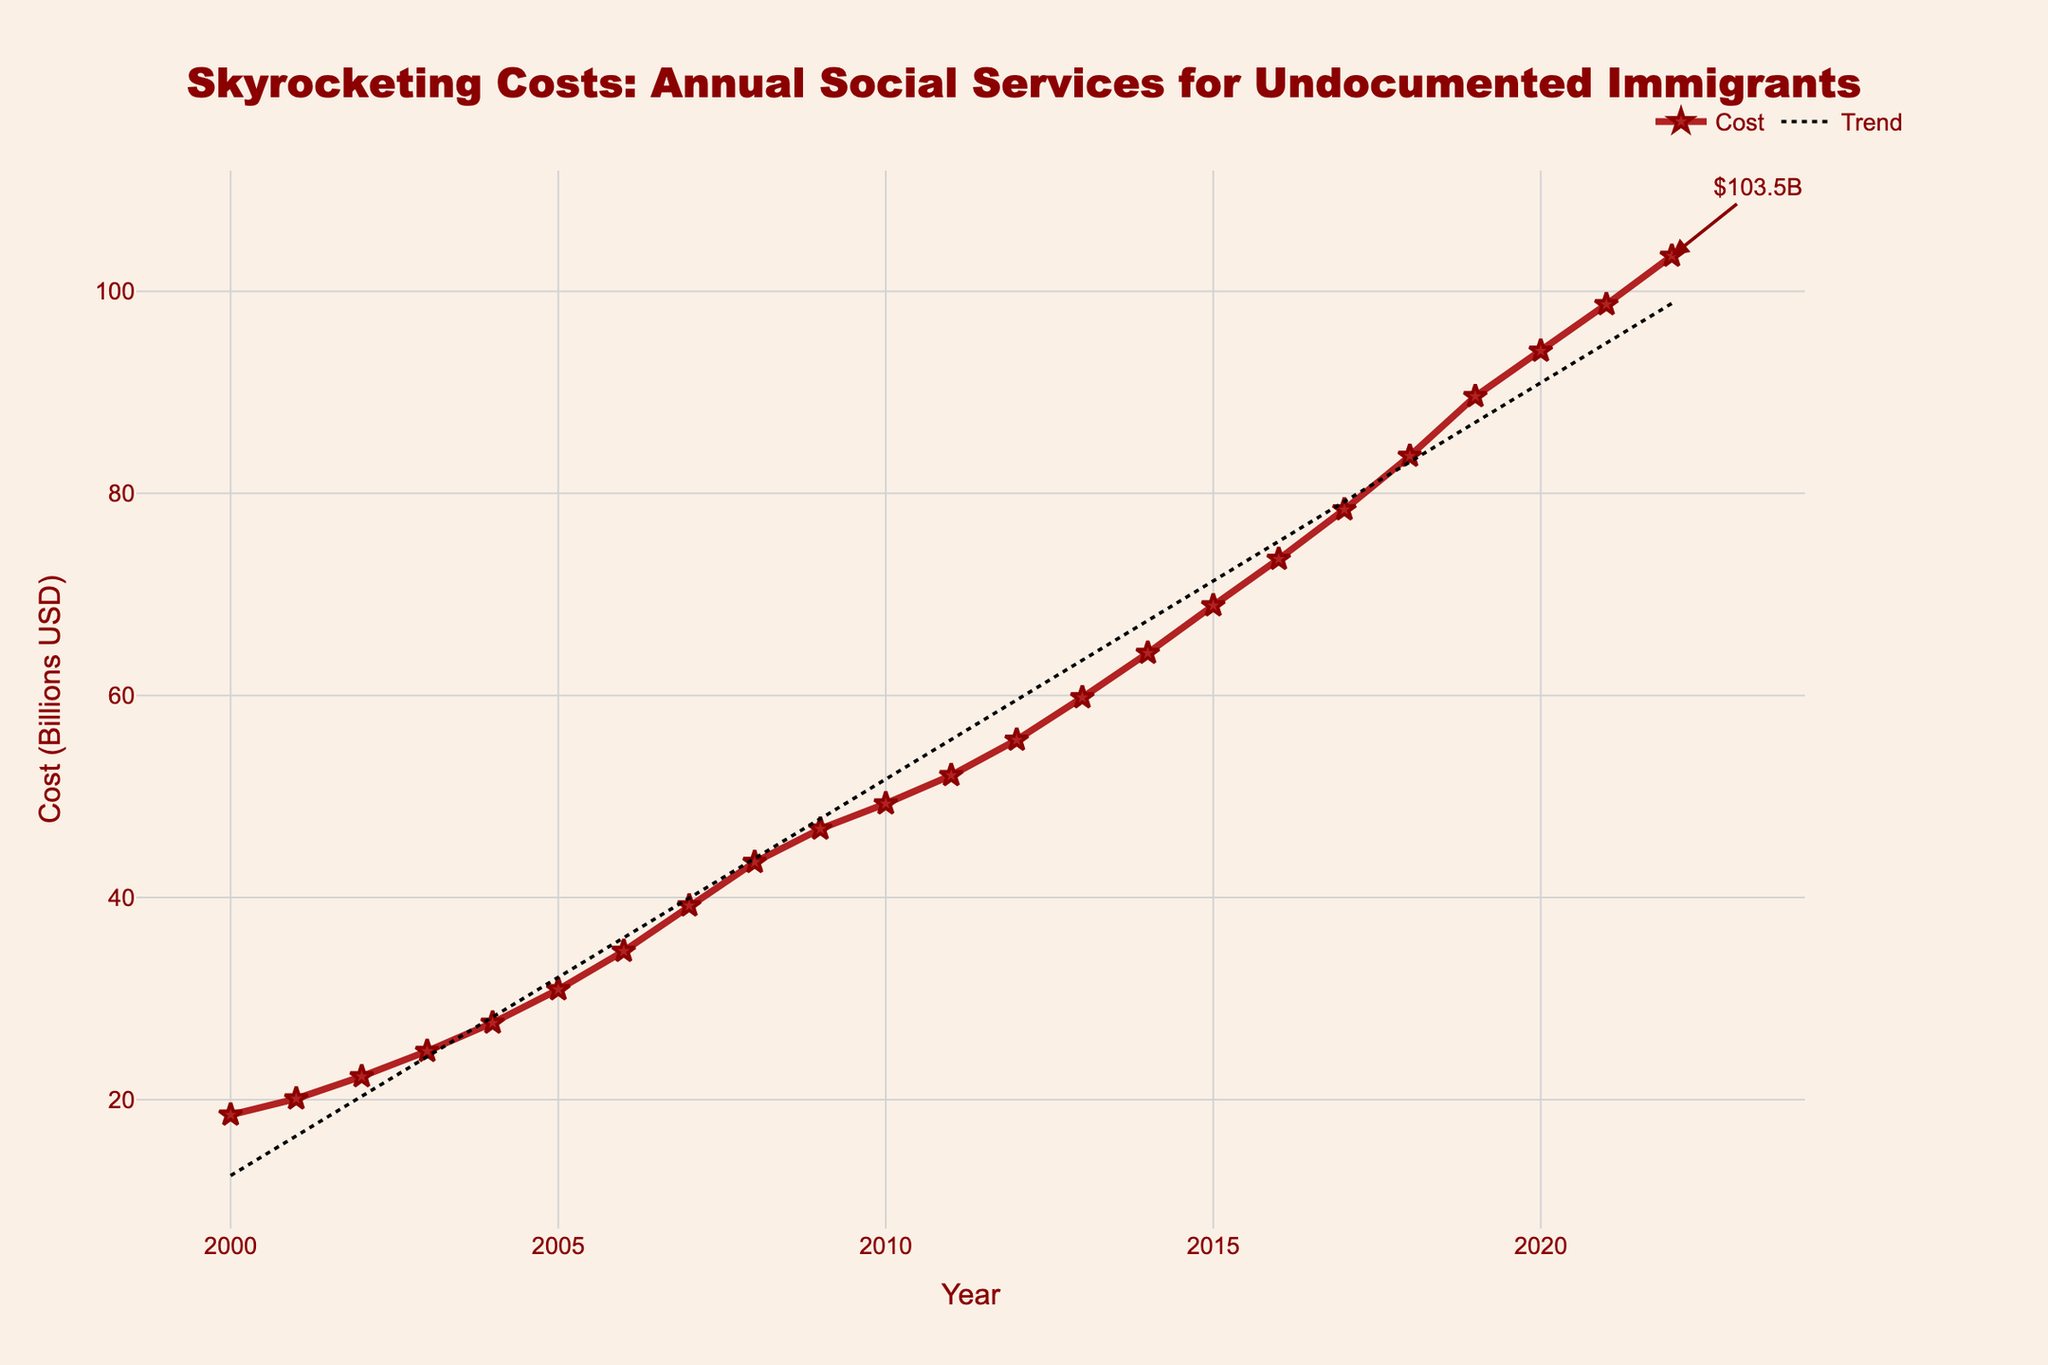What is the annual cost of social services provided to undocumented immigrants in 2022? Looking at the graph, the data point for 2022 indicates the cost is 103.5 billion USD.
Answer: 103.5 billion USD How many years after 2000 did it take for the annual cost to double the 2000 value? The cost in 2000 is 18.5 billion USD. To find when the cost doubled (reaches 37 billion USD), we look at the graph and see that in 2006, the cost is 34.7 billion USD and in 2007, it is 39.2 billion USD. Thus, it took 7 years (2007-2000).
Answer: 7 years In which year did the annual cost first exceed 50 billion USD? By checking the increasing trend in the graph, the cost first exceeds 50 billion USD in 2011.
Answer: 2011 By how much did the cost increase from 2010 to 2020? The cost in 2010 is 49.3 billion USD and in 2020 it is 94.1 billion USD. The increase is 94.1 - 49.3 = 44.8 billion USD.
Answer: 44.8 billion USD What is the difference in costs between the years 2015 and 2018? In 2015, the cost is 68.9 billion USD, and in 2018, it is 83.7 billion USD. The difference is 83.7 - 68.9 = 14.8 billion USD.
Answer: 14.8 billion USD Which year shows the highest annual increase in cost? To determine the highest increase, we must compare the differences between consecutive years. The largest increase is observed between 2018 (83.7 billion USD) and 2019 (89.6 billion USD), with an increase of 89.6 - 83.7 = 5.9 billion USD.
Answer: 2019 What is the average annual cost from 2000 to 2022? Sum all annual costs from 2000 to 2022 and divide by the number of years (23). The sum is 1231.6 billion USD. Average is 1231.6 / 23 = 53.55 billion USD.
Answer: 53.55 billion USD From which year does the cost trend line start significantly deviating above the plotted actual costs? Observing the trend line, it starts to notably deviate above the actual costs around 2020 and becomes more apparent by 2021 and 2022.
Answer: 2020 How does the cost trend from 2000 to 2022 look visually on the graph? The cost trend line shows a steady and significant upward trajectory from 2000 to 2022, indicating continuous and accelerating increase in the costs.
Answer: Steady upward trajectory By what factor has the cost increased from 2000 to 2022? The cost in 2000 is 18.5 billion USD and in 2022 it is 103.5 billion USD. The factor increase is 103.5 / 18.5 ≈ 5.59.
Answer: 5.59 